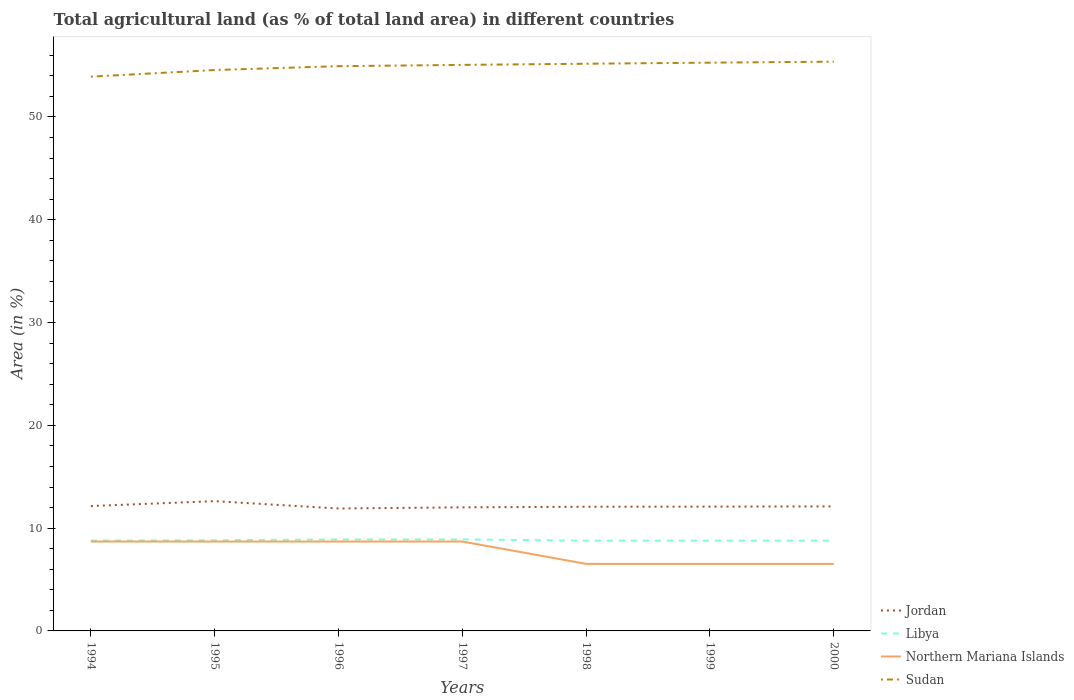Does the line corresponding to Jordan intersect with the line corresponding to Libya?
Your response must be concise. No. Is the number of lines equal to the number of legend labels?
Give a very brief answer. Yes. Across all years, what is the maximum percentage of agricultural land in Libya?
Keep it short and to the point. 8.78. What is the total percentage of agricultural land in Libya in the graph?
Provide a short and direct response. 0.12. What is the difference between the highest and the second highest percentage of agricultural land in Jordan?
Provide a succinct answer. 0.71. What is the difference between the highest and the lowest percentage of agricultural land in Northern Mariana Islands?
Offer a very short reply. 4. Is the percentage of agricultural land in Libya strictly greater than the percentage of agricultural land in Jordan over the years?
Your response must be concise. Yes. How many lines are there?
Your response must be concise. 4. How many years are there in the graph?
Your answer should be compact. 7. Does the graph contain grids?
Provide a short and direct response. No. Where does the legend appear in the graph?
Your answer should be very brief. Bottom right. How many legend labels are there?
Your response must be concise. 4. How are the legend labels stacked?
Give a very brief answer. Vertical. What is the title of the graph?
Make the answer very short. Total agricultural land (as % of total land area) in different countries. Does "Europe(developing only)" appear as one of the legend labels in the graph?
Provide a short and direct response. No. What is the label or title of the Y-axis?
Give a very brief answer. Area (in %). What is the Area (in %) of Jordan in 1994?
Provide a short and direct response. 12.15. What is the Area (in %) in Libya in 1994?
Your response must be concise. 8.79. What is the Area (in %) of Northern Mariana Islands in 1994?
Provide a short and direct response. 8.7. What is the Area (in %) in Sudan in 1994?
Your answer should be compact. 53.92. What is the Area (in %) in Jordan in 1995?
Offer a terse response. 12.62. What is the Area (in %) of Libya in 1995?
Offer a very short reply. 8.82. What is the Area (in %) of Northern Mariana Islands in 1995?
Ensure brevity in your answer.  8.7. What is the Area (in %) in Sudan in 1995?
Your answer should be compact. 54.56. What is the Area (in %) in Jordan in 1996?
Your response must be concise. 11.91. What is the Area (in %) in Libya in 1996?
Give a very brief answer. 8.9. What is the Area (in %) in Northern Mariana Islands in 1996?
Keep it short and to the point. 8.7. What is the Area (in %) of Sudan in 1996?
Keep it short and to the point. 54.94. What is the Area (in %) of Jordan in 1997?
Offer a very short reply. 12.02. What is the Area (in %) of Libya in 1997?
Your response must be concise. 8.9. What is the Area (in %) in Northern Mariana Islands in 1997?
Provide a short and direct response. 8.7. What is the Area (in %) in Sudan in 1997?
Your answer should be very brief. 55.06. What is the Area (in %) in Jordan in 1998?
Offer a very short reply. 12.08. What is the Area (in %) of Libya in 1998?
Give a very brief answer. 8.78. What is the Area (in %) of Northern Mariana Islands in 1998?
Offer a very short reply. 6.52. What is the Area (in %) in Sudan in 1998?
Ensure brevity in your answer.  55.18. What is the Area (in %) in Jordan in 1999?
Make the answer very short. 12.09. What is the Area (in %) of Libya in 1999?
Your response must be concise. 8.78. What is the Area (in %) of Northern Mariana Islands in 1999?
Keep it short and to the point. 6.52. What is the Area (in %) in Sudan in 1999?
Make the answer very short. 55.28. What is the Area (in %) of Jordan in 2000?
Your answer should be compact. 12.11. What is the Area (in %) of Libya in 2000?
Your answer should be compact. 8.78. What is the Area (in %) of Northern Mariana Islands in 2000?
Give a very brief answer. 6.52. What is the Area (in %) of Sudan in 2000?
Your response must be concise. 55.38. Across all years, what is the maximum Area (in %) in Jordan?
Offer a terse response. 12.62. Across all years, what is the maximum Area (in %) of Libya?
Ensure brevity in your answer.  8.9. Across all years, what is the maximum Area (in %) of Northern Mariana Islands?
Your answer should be compact. 8.7. Across all years, what is the maximum Area (in %) of Sudan?
Provide a succinct answer. 55.38. Across all years, what is the minimum Area (in %) of Jordan?
Provide a short and direct response. 11.91. Across all years, what is the minimum Area (in %) in Libya?
Your answer should be compact. 8.78. Across all years, what is the minimum Area (in %) in Northern Mariana Islands?
Ensure brevity in your answer.  6.52. Across all years, what is the minimum Area (in %) of Sudan?
Your response must be concise. 53.92. What is the total Area (in %) of Jordan in the graph?
Ensure brevity in your answer.  85. What is the total Area (in %) of Libya in the graph?
Your answer should be very brief. 61.76. What is the total Area (in %) of Northern Mariana Islands in the graph?
Offer a terse response. 54.35. What is the total Area (in %) of Sudan in the graph?
Ensure brevity in your answer.  384.33. What is the difference between the Area (in %) of Jordan in 1994 and that in 1995?
Ensure brevity in your answer.  -0.48. What is the difference between the Area (in %) in Libya in 1994 and that in 1995?
Your answer should be very brief. -0.02. What is the difference between the Area (in %) of Northern Mariana Islands in 1994 and that in 1995?
Your response must be concise. 0. What is the difference between the Area (in %) of Sudan in 1994 and that in 1995?
Ensure brevity in your answer.  -0.64. What is the difference between the Area (in %) in Jordan in 1994 and that in 1996?
Offer a very short reply. 0.24. What is the difference between the Area (in %) of Libya in 1994 and that in 1996?
Provide a succinct answer. -0.11. What is the difference between the Area (in %) in Sudan in 1994 and that in 1996?
Offer a terse response. -1.02. What is the difference between the Area (in %) of Jordan in 1994 and that in 1997?
Make the answer very short. 0.12. What is the difference between the Area (in %) of Libya in 1994 and that in 1997?
Keep it short and to the point. -0.11. What is the difference between the Area (in %) of Northern Mariana Islands in 1994 and that in 1997?
Ensure brevity in your answer.  0. What is the difference between the Area (in %) in Sudan in 1994 and that in 1997?
Keep it short and to the point. -1.14. What is the difference between the Area (in %) in Jordan in 1994 and that in 1998?
Keep it short and to the point. 0.07. What is the difference between the Area (in %) of Libya in 1994 and that in 1998?
Your answer should be compact. 0.01. What is the difference between the Area (in %) in Northern Mariana Islands in 1994 and that in 1998?
Make the answer very short. 2.17. What is the difference between the Area (in %) of Sudan in 1994 and that in 1998?
Ensure brevity in your answer.  -1.26. What is the difference between the Area (in %) in Jordan in 1994 and that in 1999?
Offer a very short reply. 0.06. What is the difference between the Area (in %) in Libya in 1994 and that in 1999?
Make the answer very short. 0.01. What is the difference between the Area (in %) of Northern Mariana Islands in 1994 and that in 1999?
Give a very brief answer. 2.17. What is the difference between the Area (in %) of Sudan in 1994 and that in 1999?
Your answer should be compact. -1.36. What is the difference between the Area (in %) of Jordan in 1994 and that in 2000?
Offer a terse response. 0.03. What is the difference between the Area (in %) of Libya in 1994 and that in 2000?
Keep it short and to the point. 0.01. What is the difference between the Area (in %) of Northern Mariana Islands in 1994 and that in 2000?
Provide a succinct answer. 2.17. What is the difference between the Area (in %) of Sudan in 1994 and that in 2000?
Provide a short and direct response. -1.46. What is the difference between the Area (in %) of Jordan in 1995 and that in 1996?
Provide a succinct answer. 0.71. What is the difference between the Area (in %) of Libya in 1995 and that in 1996?
Make the answer very short. -0.09. What is the difference between the Area (in %) of Northern Mariana Islands in 1995 and that in 1996?
Provide a short and direct response. 0. What is the difference between the Area (in %) in Sudan in 1995 and that in 1996?
Offer a very short reply. -0.38. What is the difference between the Area (in %) of Jordan in 1995 and that in 1997?
Provide a succinct answer. 0.6. What is the difference between the Area (in %) of Libya in 1995 and that in 1997?
Make the answer very short. -0.09. What is the difference between the Area (in %) of Northern Mariana Islands in 1995 and that in 1997?
Ensure brevity in your answer.  0. What is the difference between the Area (in %) of Sudan in 1995 and that in 1997?
Offer a terse response. -0.5. What is the difference between the Area (in %) of Jordan in 1995 and that in 1998?
Keep it short and to the point. 0.54. What is the difference between the Area (in %) of Libya in 1995 and that in 1998?
Give a very brief answer. 0.04. What is the difference between the Area (in %) in Northern Mariana Islands in 1995 and that in 1998?
Your answer should be compact. 2.17. What is the difference between the Area (in %) in Sudan in 1995 and that in 1998?
Offer a terse response. -0.61. What is the difference between the Area (in %) in Jordan in 1995 and that in 1999?
Give a very brief answer. 0.53. What is the difference between the Area (in %) of Libya in 1995 and that in 1999?
Keep it short and to the point. 0.04. What is the difference between the Area (in %) of Northern Mariana Islands in 1995 and that in 1999?
Offer a terse response. 2.17. What is the difference between the Area (in %) of Sudan in 1995 and that in 1999?
Give a very brief answer. -0.72. What is the difference between the Area (in %) of Jordan in 1995 and that in 2000?
Offer a very short reply. 0.51. What is the difference between the Area (in %) of Libya in 1995 and that in 2000?
Provide a short and direct response. 0.04. What is the difference between the Area (in %) of Northern Mariana Islands in 1995 and that in 2000?
Give a very brief answer. 2.17. What is the difference between the Area (in %) of Sudan in 1995 and that in 2000?
Offer a very short reply. -0.81. What is the difference between the Area (in %) of Jordan in 1996 and that in 1997?
Your answer should be very brief. -0.11. What is the difference between the Area (in %) in Northern Mariana Islands in 1996 and that in 1997?
Your answer should be very brief. 0. What is the difference between the Area (in %) in Sudan in 1996 and that in 1997?
Offer a terse response. -0.12. What is the difference between the Area (in %) of Jordan in 1996 and that in 1998?
Give a very brief answer. -0.17. What is the difference between the Area (in %) of Libya in 1996 and that in 1998?
Your answer should be very brief. 0.12. What is the difference between the Area (in %) of Northern Mariana Islands in 1996 and that in 1998?
Ensure brevity in your answer.  2.17. What is the difference between the Area (in %) in Sudan in 1996 and that in 1998?
Provide a succinct answer. -0.24. What is the difference between the Area (in %) in Jordan in 1996 and that in 1999?
Ensure brevity in your answer.  -0.18. What is the difference between the Area (in %) of Libya in 1996 and that in 1999?
Make the answer very short. 0.12. What is the difference between the Area (in %) in Northern Mariana Islands in 1996 and that in 1999?
Your answer should be very brief. 2.17. What is the difference between the Area (in %) of Sudan in 1996 and that in 1999?
Ensure brevity in your answer.  -0.34. What is the difference between the Area (in %) in Jordan in 1996 and that in 2000?
Offer a terse response. -0.2. What is the difference between the Area (in %) of Libya in 1996 and that in 2000?
Ensure brevity in your answer.  0.12. What is the difference between the Area (in %) in Northern Mariana Islands in 1996 and that in 2000?
Your response must be concise. 2.17. What is the difference between the Area (in %) in Sudan in 1996 and that in 2000?
Ensure brevity in your answer.  -0.44. What is the difference between the Area (in %) of Jordan in 1997 and that in 1998?
Offer a very short reply. -0.06. What is the difference between the Area (in %) in Libya in 1997 and that in 1998?
Keep it short and to the point. 0.12. What is the difference between the Area (in %) in Northern Mariana Islands in 1997 and that in 1998?
Give a very brief answer. 2.17. What is the difference between the Area (in %) in Sudan in 1997 and that in 1998?
Your answer should be very brief. -0.11. What is the difference between the Area (in %) in Jordan in 1997 and that in 1999?
Your response must be concise. -0.07. What is the difference between the Area (in %) in Libya in 1997 and that in 1999?
Offer a terse response. 0.12. What is the difference between the Area (in %) in Northern Mariana Islands in 1997 and that in 1999?
Provide a succinct answer. 2.17. What is the difference between the Area (in %) of Sudan in 1997 and that in 1999?
Your response must be concise. -0.22. What is the difference between the Area (in %) of Jordan in 1997 and that in 2000?
Offer a terse response. -0.09. What is the difference between the Area (in %) in Libya in 1997 and that in 2000?
Ensure brevity in your answer.  0.12. What is the difference between the Area (in %) in Northern Mariana Islands in 1997 and that in 2000?
Your answer should be very brief. 2.17. What is the difference between the Area (in %) in Sudan in 1997 and that in 2000?
Provide a short and direct response. -0.31. What is the difference between the Area (in %) of Jordan in 1998 and that in 1999?
Make the answer very short. -0.01. What is the difference between the Area (in %) of Libya in 1998 and that in 1999?
Your answer should be compact. 0. What is the difference between the Area (in %) in Sudan in 1998 and that in 1999?
Make the answer very short. -0.11. What is the difference between the Area (in %) of Jordan in 1998 and that in 2000?
Provide a succinct answer. -0.03. What is the difference between the Area (in %) of Northern Mariana Islands in 1998 and that in 2000?
Give a very brief answer. 0. What is the difference between the Area (in %) of Sudan in 1998 and that in 2000?
Your answer should be very brief. -0.2. What is the difference between the Area (in %) of Jordan in 1999 and that in 2000?
Offer a very short reply. -0.02. What is the difference between the Area (in %) of Libya in 1999 and that in 2000?
Your response must be concise. 0. What is the difference between the Area (in %) in Sudan in 1999 and that in 2000?
Offer a terse response. -0.09. What is the difference between the Area (in %) of Jordan in 1994 and the Area (in %) of Libya in 1995?
Your response must be concise. 3.33. What is the difference between the Area (in %) of Jordan in 1994 and the Area (in %) of Northern Mariana Islands in 1995?
Your answer should be compact. 3.45. What is the difference between the Area (in %) of Jordan in 1994 and the Area (in %) of Sudan in 1995?
Your answer should be compact. -42.42. What is the difference between the Area (in %) in Libya in 1994 and the Area (in %) in Northern Mariana Islands in 1995?
Your answer should be compact. 0.1. What is the difference between the Area (in %) in Libya in 1994 and the Area (in %) in Sudan in 1995?
Offer a very short reply. -45.77. What is the difference between the Area (in %) of Northern Mariana Islands in 1994 and the Area (in %) of Sudan in 1995?
Offer a terse response. -45.87. What is the difference between the Area (in %) of Jordan in 1994 and the Area (in %) of Libya in 1996?
Your response must be concise. 3.25. What is the difference between the Area (in %) of Jordan in 1994 and the Area (in %) of Northern Mariana Islands in 1996?
Your answer should be compact. 3.45. What is the difference between the Area (in %) in Jordan in 1994 and the Area (in %) in Sudan in 1996?
Your answer should be very brief. -42.79. What is the difference between the Area (in %) of Libya in 1994 and the Area (in %) of Northern Mariana Islands in 1996?
Offer a terse response. 0.1. What is the difference between the Area (in %) of Libya in 1994 and the Area (in %) of Sudan in 1996?
Give a very brief answer. -46.15. What is the difference between the Area (in %) of Northern Mariana Islands in 1994 and the Area (in %) of Sudan in 1996?
Your answer should be compact. -46.24. What is the difference between the Area (in %) in Jordan in 1994 and the Area (in %) in Libya in 1997?
Provide a succinct answer. 3.25. What is the difference between the Area (in %) of Jordan in 1994 and the Area (in %) of Northern Mariana Islands in 1997?
Keep it short and to the point. 3.45. What is the difference between the Area (in %) in Jordan in 1994 and the Area (in %) in Sudan in 1997?
Keep it short and to the point. -42.92. What is the difference between the Area (in %) in Libya in 1994 and the Area (in %) in Northern Mariana Islands in 1997?
Your answer should be very brief. 0.1. What is the difference between the Area (in %) in Libya in 1994 and the Area (in %) in Sudan in 1997?
Keep it short and to the point. -46.27. What is the difference between the Area (in %) of Northern Mariana Islands in 1994 and the Area (in %) of Sudan in 1997?
Provide a succinct answer. -46.37. What is the difference between the Area (in %) in Jordan in 1994 and the Area (in %) in Libya in 1998?
Your answer should be compact. 3.37. What is the difference between the Area (in %) of Jordan in 1994 and the Area (in %) of Northern Mariana Islands in 1998?
Your response must be concise. 5.63. What is the difference between the Area (in %) of Jordan in 1994 and the Area (in %) of Sudan in 1998?
Keep it short and to the point. -43.03. What is the difference between the Area (in %) of Libya in 1994 and the Area (in %) of Northern Mariana Islands in 1998?
Provide a short and direct response. 2.27. What is the difference between the Area (in %) of Libya in 1994 and the Area (in %) of Sudan in 1998?
Make the answer very short. -46.38. What is the difference between the Area (in %) of Northern Mariana Islands in 1994 and the Area (in %) of Sudan in 1998?
Ensure brevity in your answer.  -46.48. What is the difference between the Area (in %) in Jordan in 1994 and the Area (in %) in Libya in 1999?
Your response must be concise. 3.37. What is the difference between the Area (in %) in Jordan in 1994 and the Area (in %) in Northern Mariana Islands in 1999?
Offer a terse response. 5.63. What is the difference between the Area (in %) of Jordan in 1994 and the Area (in %) of Sudan in 1999?
Keep it short and to the point. -43.13. What is the difference between the Area (in %) in Libya in 1994 and the Area (in %) in Northern Mariana Islands in 1999?
Make the answer very short. 2.27. What is the difference between the Area (in %) of Libya in 1994 and the Area (in %) of Sudan in 1999?
Give a very brief answer. -46.49. What is the difference between the Area (in %) of Northern Mariana Islands in 1994 and the Area (in %) of Sudan in 1999?
Your response must be concise. -46.59. What is the difference between the Area (in %) in Jordan in 1994 and the Area (in %) in Libya in 2000?
Provide a succinct answer. 3.37. What is the difference between the Area (in %) in Jordan in 1994 and the Area (in %) in Northern Mariana Islands in 2000?
Make the answer very short. 5.63. What is the difference between the Area (in %) of Jordan in 1994 and the Area (in %) of Sudan in 2000?
Offer a terse response. -43.23. What is the difference between the Area (in %) in Libya in 1994 and the Area (in %) in Northern Mariana Islands in 2000?
Give a very brief answer. 2.27. What is the difference between the Area (in %) in Libya in 1994 and the Area (in %) in Sudan in 2000?
Your answer should be compact. -46.58. What is the difference between the Area (in %) in Northern Mariana Islands in 1994 and the Area (in %) in Sudan in 2000?
Offer a very short reply. -46.68. What is the difference between the Area (in %) of Jordan in 1995 and the Area (in %) of Libya in 1996?
Make the answer very short. 3.72. What is the difference between the Area (in %) in Jordan in 1995 and the Area (in %) in Northern Mariana Islands in 1996?
Offer a terse response. 3.93. What is the difference between the Area (in %) of Jordan in 1995 and the Area (in %) of Sudan in 1996?
Give a very brief answer. -42.32. What is the difference between the Area (in %) of Libya in 1995 and the Area (in %) of Northern Mariana Islands in 1996?
Keep it short and to the point. 0.12. What is the difference between the Area (in %) in Libya in 1995 and the Area (in %) in Sudan in 1996?
Your answer should be very brief. -46.12. What is the difference between the Area (in %) in Northern Mariana Islands in 1995 and the Area (in %) in Sudan in 1996?
Provide a short and direct response. -46.24. What is the difference between the Area (in %) of Jordan in 1995 and the Area (in %) of Libya in 1997?
Ensure brevity in your answer.  3.72. What is the difference between the Area (in %) in Jordan in 1995 and the Area (in %) in Northern Mariana Islands in 1997?
Ensure brevity in your answer.  3.93. What is the difference between the Area (in %) of Jordan in 1995 and the Area (in %) of Sudan in 1997?
Keep it short and to the point. -42.44. What is the difference between the Area (in %) of Libya in 1995 and the Area (in %) of Northern Mariana Islands in 1997?
Offer a very short reply. 0.12. What is the difference between the Area (in %) of Libya in 1995 and the Area (in %) of Sudan in 1997?
Ensure brevity in your answer.  -46.25. What is the difference between the Area (in %) of Northern Mariana Islands in 1995 and the Area (in %) of Sudan in 1997?
Offer a very short reply. -46.37. What is the difference between the Area (in %) of Jordan in 1995 and the Area (in %) of Libya in 1998?
Make the answer very short. 3.84. What is the difference between the Area (in %) in Jordan in 1995 and the Area (in %) in Northern Mariana Islands in 1998?
Ensure brevity in your answer.  6.1. What is the difference between the Area (in %) of Jordan in 1995 and the Area (in %) of Sudan in 1998?
Provide a short and direct response. -42.55. What is the difference between the Area (in %) in Libya in 1995 and the Area (in %) in Northern Mariana Islands in 1998?
Keep it short and to the point. 2.3. What is the difference between the Area (in %) of Libya in 1995 and the Area (in %) of Sudan in 1998?
Your answer should be compact. -46.36. What is the difference between the Area (in %) of Northern Mariana Islands in 1995 and the Area (in %) of Sudan in 1998?
Your answer should be very brief. -46.48. What is the difference between the Area (in %) in Jordan in 1995 and the Area (in %) in Libya in 1999?
Give a very brief answer. 3.84. What is the difference between the Area (in %) of Jordan in 1995 and the Area (in %) of Northern Mariana Islands in 1999?
Your answer should be very brief. 6.1. What is the difference between the Area (in %) in Jordan in 1995 and the Area (in %) in Sudan in 1999?
Your answer should be compact. -42.66. What is the difference between the Area (in %) of Libya in 1995 and the Area (in %) of Northern Mariana Islands in 1999?
Your answer should be compact. 2.3. What is the difference between the Area (in %) of Libya in 1995 and the Area (in %) of Sudan in 1999?
Offer a very short reply. -46.47. What is the difference between the Area (in %) in Northern Mariana Islands in 1995 and the Area (in %) in Sudan in 1999?
Offer a very short reply. -46.59. What is the difference between the Area (in %) of Jordan in 1995 and the Area (in %) of Libya in 2000?
Your answer should be very brief. 3.84. What is the difference between the Area (in %) in Jordan in 1995 and the Area (in %) in Northern Mariana Islands in 2000?
Your response must be concise. 6.1. What is the difference between the Area (in %) of Jordan in 1995 and the Area (in %) of Sudan in 2000?
Offer a terse response. -42.75. What is the difference between the Area (in %) of Libya in 1995 and the Area (in %) of Northern Mariana Islands in 2000?
Provide a short and direct response. 2.3. What is the difference between the Area (in %) in Libya in 1995 and the Area (in %) in Sudan in 2000?
Your answer should be compact. -46.56. What is the difference between the Area (in %) of Northern Mariana Islands in 1995 and the Area (in %) of Sudan in 2000?
Provide a succinct answer. -46.68. What is the difference between the Area (in %) in Jordan in 1996 and the Area (in %) in Libya in 1997?
Your answer should be compact. 3.01. What is the difference between the Area (in %) in Jordan in 1996 and the Area (in %) in Northern Mariana Islands in 1997?
Give a very brief answer. 3.21. What is the difference between the Area (in %) of Jordan in 1996 and the Area (in %) of Sudan in 1997?
Provide a succinct answer. -43.15. What is the difference between the Area (in %) of Libya in 1996 and the Area (in %) of Northern Mariana Islands in 1997?
Provide a short and direct response. 0.21. What is the difference between the Area (in %) of Libya in 1996 and the Area (in %) of Sudan in 1997?
Offer a very short reply. -46.16. What is the difference between the Area (in %) of Northern Mariana Islands in 1996 and the Area (in %) of Sudan in 1997?
Provide a short and direct response. -46.37. What is the difference between the Area (in %) in Jordan in 1996 and the Area (in %) in Libya in 1998?
Give a very brief answer. 3.13. What is the difference between the Area (in %) of Jordan in 1996 and the Area (in %) of Northern Mariana Islands in 1998?
Your response must be concise. 5.39. What is the difference between the Area (in %) in Jordan in 1996 and the Area (in %) in Sudan in 1998?
Provide a short and direct response. -43.27. What is the difference between the Area (in %) of Libya in 1996 and the Area (in %) of Northern Mariana Islands in 1998?
Give a very brief answer. 2.38. What is the difference between the Area (in %) in Libya in 1996 and the Area (in %) in Sudan in 1998?
Offer a terse response. -46.27. What is the difference between the Area (in %) of Northern Mariana Islands in 1996 and the Area (in %) of Sudan in 1998?
Keep it short and to the point. -46.48. What is the difference between the Area (in %) of Jordan in 1996 and the Area (in %) of Libya in 1999?
Ensure brevity in your answer.  3.13. What is the difference between the Area (in %) of Jordan in 1996 and the Area (in %) of Northern Mariana Islands in 1999?
Offer a very short reply. 5.39. What is the difference between the Area (in %) of Jordan in 1996 and the Area (in %) of Sudan in 1999?
Offer a very short reply. -43.37. What is the difference between the Area (in %) of Libya in 1996 and the Area (in %) of Northern Mariana Islands in 1999?
Your answer should be compact. 2.38. What is the difference between the Area (in %) in Libya in 1996 and the Area (in %) in Sudan in 1999?
Make the answer very short. -46.38. What is the difference between the Area (in %) of Northern Mariana Islands in 1996 and the Area (in %) of Sudan in 1999?
Offer a very short reply. -46.59. What is the difference between the Area (in %) in Jordan in 1996 and the Area (in %) in Libya in 2000?
Your answer should be very brief. 3.13. What is the difference between the Area (in %) in Jordan in 1996 and the Area (in %) in Northern Mariana Islands in 2000?
Provide a succinct answer. 5.39. What is the difference between the Area (in %) of Jordan in 1996 and the Area (in %) of Sudan in 2000?
Your response must be concise. -43.47. What is the difference between the Area (in %) of Libya in 1996 and the Area (in %) of Northern Mariana Islands in 2000?
Give a very brief answer. 2.38. What is the difference between the Area (in %) of Libya in 1996 and the Area (in %) of Sudan in 2000?
Provide a succinct answer. -46.47. What is the difference between the Area (in %) in Northern Mariana Islands in 1996 and the Area (in %) in Sudan in 2000?
Your answer should be compact. -46.68. What is the difference between the Area (in %) in Jordan in 1997 and the Area (in %) in Libya in 1998?
Your answer should be compact. 3.24. What is the difference between the Area (in %) of Jordan in 1997 and the Area (in %) of Northern Mariana Islands in 1998?
Your answer should be compact. 5.5. What is the difference between the Area (in %) in Jordan in 1997 and the Area (in %) in Sudan in 1998?
Keep it short and to the point. -43.15. What is the difference between the Area (in %) of Libya in 1997 and the Area (in %) of Northern Mariana Islands in 1998?
Provide a succinct answer. 2.38. What is the difference between the Area (in %) of Libya in 1997 and the Area (in %) of Sudan in 1998?
Make the answer very short. -46.27. What is the difference between the Area (in %) of Northern Mariana Islands in 1997 and the Area (in %) of Sudan in 1998?
Your response must be concise. -46.48. What is the difference between the Area (in %) of Jordan in 1997 and the Area (in %) of Libya in 1999?
Your response must be concise. 3.24. What is the difference between the Area (in %) of Jordan in 1997 and the Area (in %) of Northern Mariana Islands in 1999?
Provide a short and direct response. 5.5. What is the difference between the Area (in %) of Jordan in 1997 and the Area (in %) of Sudan in 1999?
Make the answer very short. -43.26. What is the difference between the Area (in %) in Libya in 1997 and the Area (in %) in Northern Mariana Islands in 1999?
Your answer should be very brief. 2.38. What is the difference between the Area (in %) in Libya in 1997 and the Area (in %) in Sudan in 1999?
Offer a very short reply. -46.38. What is the difference between the Area (in %) of Northern Mariana Islands in 1997 and the Area (in %) of Sudan in 1999?
Give a very brief answer. -46.59. What is the difference between the Area (in %) of Jordan in 1997 and the Area (in %) of Libya in 2000?
Provide a succinct answer. 3.24. What is the difference between the Area (in %) in Jordan in 1997 and the Area (in %) in Northern Mariana Islands in 2000?
Your answer should be compact. 5.5. What is the difference between the Area (in %) in Jordan in 1997 and the Area (in %) in Sudan in 2000?
Your answer should be very brief. -43.35. What is the difference between the Area (in %) in Libya in 1997 and the Area (in %) in Northern Mariana Islands in 2000?
Ensure brevity in your answer.  2.38. What is the difference between the Area (in %) of Libya in 1997 and the Area (in %) of Sudan in 2000?
Provide a succinct answer. -46.47. What is the difference between the Area (in %) in Northern Mariana Islands in 1997 and the Area (in %) in Sudan in 2000?
Keep it short and to the point. -46.68. What is the difference between the Area (in %) of Jordan in 1998 and the Area (in %) of Northern Mariana Islands in 1999?
Offer a terse response. 5.56. What is the difference between the Area (in %) of Jordan in 1998 and the Area (in %) of Sudan in 1999?
Give a very brief answer. -43.2. What is the difference between the Area (in %) in Libya in 1998 and the Area (in %) in Northern Mariana Islands in 1999?
Make the answer very short. 2.26. What is the difference between the Area (in %) of Libya in 1998 and the Area (in %) of Sudan in 1999?
Offer a very short reply. -46.5. What is the difference between the Area (in %) of Northern Mariana Islands in 1998 and the Area (in %) of Sudan in 1999?
Your answer should be very brief. -48.76. What is the difference between the Area (in %) of Jordan in 1998 and the Area (in %) of Northern Mariana Islands in 2000?
Offer a terse response. 5.56. What is the difference between the Area (in %) of Jordan in 1998 and the Area (in %) of Sudan in 2000?
Your answer should be very brief. -43.3. What is the difference between the Area (in %) of Libya in 1998 and the Area (in %) of Northern Mariana Islands in 2000?
Offer a terse response. 2.26. What is the difference between the Area (in %) of Libya in 1998 and the Area (in %) of Sudan in 2000?
Offer a terse response. -46.6. What is the difference between the Area (in %) in Northern Mariana Islands in 1998 and the Area (in %) in Sudan in 2000?
Provide a succinct answer. -48.85. What is the difference between the Area (in %) of Jordan in 1999 and the Area (in %) of Libya in 2000?
Provide a short and direct response. 3.31. What is the difference between the Area (in %) in Jordan in 1999 and the Area (in %) in Northern Mariana Islands in 2000?
Ensure brevity in your answer.  5.57. What is the difference between the Area (in %) of Jordan in 1999 and the Area (in %) of Sudan in 2000?
Give a very brief answer. -43.28. What is the difference between the Area (in %) of Libya in 1999 and the Area (in %) of Northern Mariana Islands in 2000?
Provide a short and direct response. 2.26. What is the difference between the Area (in %) in Libya in 1999 and the Area (in %) in Sudan in 2000?
Give a very brief answer. -46.6. What is the difference between the Area (in %) in Northern Mariana Islands in 1999 and the Area (in %) in Sudan in 2000?
Your answer should be very brief. -48.85. What is the average Area (in %) in Jordan per year?
Your response must be concise. 12.14. What is the average Area (in %) of Libya per year?
Provide a short and direct response. 8.82. What is the average Area (in %) of Northern Mariana Islands per year?
Give a very brief answer. 7.76. What is the average Area (in %) of Sudan per year?
Give a very brief answer. 54.9. In the year 1994, what is the difference between the Area (in %) of Jordan and Area (in %) of Libya?
Give a very brief answer. 3.35. In the year 1994, what is the difference between the Area (in %) in Jordan and Area (in %) in Northern Mariana Islands?
Your answer should be very brief. 3.45. In the year 1994, what is the difference between the Area (in %) in Jordan and Area (in %) in Sudan?
Ensure brevity in your answer.  -41.77. In the year 1994, what is the difference between the Area (in %) in Libya and Area (in %) in Northern Mariana Islands?
Provide a short and direct response. 0.1. In the year 1994, what is the difference between the Area (in %) of Libya and Area (in %) of Sudan?
Provide a short and direct response. -45.13. In the year 1994, what is the difference between the Area (in %) in Northern Mariana Islands and Area (in %) in Sudan?
Offer a terse response. -45.22. In the year 1995, what is the difference between the Area (in %) of Jordan and Area (in %) of Libya?
Give a very brief answer. 3.81. In the year 1995, what is the difference between the Area (in %) of Jordan and Area (in %) of Northern Mariana Islands?
Offer a very short reply. 3.93. In the year 1995, what is the difference between the Area (in %) in Jordan and Area (in %) in Sudan?
Keep it short and to the point. -41.94. In the year 1995, what is the difference between the Area (in %) in Libya and Area (in %) in Northern Mariana Islands?
Ensure brevity in your answer.  0.12. In the year 1995, what is the difference between the Area (in %) of Libya and Area (in %) of Sudan?
Your answer should be very brief. -45.75. In the year 1995, what is the difference between the Area (in %) of Northern Mariana Islands and Area (in %) of Sudan?
Make the answer very short. -45.87. In the year 1996, what is the difference between the Area (in %) of Jordan and Area (in %) of Libya?
Your answer should be compact. 3.01. In the year 1996, what is the difference between the Area (in %) of Jordan and Area (in %) of Northern Mariana Islands?
Your answer should be very brief. 3.21. In the year 1996, what is the difference between the Area (in %) of Jordan and Area (in %) of Sudan?
Provide a succinct answer. -43.03. In the year 1996, what is the difference between the Area (in %) in Libya and Area (in %) in Northern Mariana Islands?
Your answer should be very brief. 0.21. In the year 1996, what is the difference between the Area (in %) of Libya and Area (in %) of Sudan?
Keep it short and to the point. -46.04. In the year 1996, what is the difference between the Area (in %) of Northern Mariana Islands and Area (in %) of Sudan?
Your answer should be very brief. -46.24. In the year 1997, what is the difference between the Area (in %) of Jordan and Area (in %) of Libya?
Your answer should be compact. 3.12. In the year 1997, what is the difference between the Area (in %) in Jordan and Area (in %) in Northern Mariana Islands?
Give a very brief answer. 3.33. In the year 1997, what is the difference between the Area (in %) in Jordan and Area (in %) in Sudan?
Your answer should be compact. -43.04. In the year 1997, what is the difference between the Area (in %) of Libya and Area (in %) of Northern Mariana Islands?
Your answer should be very brief. 0.21. In the year 1997, what is the difference between the Area (in %) of Libya and Area (in %) of Sudan?
Ensure brevity in your answer.  -46.16. In the year 1997, what is the difference between the Area (in %) of Northern Mariana Islands and Area (in %) of Sudan?
Offer a terse response. -46.37. In the year 1998, what is the difference between the Area (in %) in Jordan and Area (in %) in Libya?
Offer a terse response. 3.3. In the year 1998, what is the difference between the Area (in %) of Jordan and Area (in %) of Northern Mariana Islands?
Offer a terse response. 5.56. In the year 1998, what is the difference between the Area (in %) in Jordan and Area (in %) in Sudan?
Your answer should be very brief. -43.1. In the year 1998, what is the difference between the Area (in %) of Libya and Area (in %) of Northern Mariana Islands?
Offer a terse response. 2.26. In the year 1998, what is the difference between the Area (in %) of Libya and Area (in %) of Sudan?
Offer a terse response. -46.4. In the year 1998, what is the difference between the Area (in %) of Northern Mariana Islands and Area (in %) of Sudan?
Your answer should be compact. -48.66. In the year 1999, what is the difference between the Area (in %) of Jordan and Area (in %) of Libya?
Your response must be concise. 3.31. In the year 1999, what is the difference between the Area (in %) in Jordan and Area (in %) in Northern Mariana Islands?
Offer a very short reply. 5.57. In the year 1999, what is the difference between the Area (in %) of Jordan and Area (in %) of Sudan?
Ensure brevity in your answer.  -43.19. In the year 1999, what is the difference between the Area (in %) in Libya and Area (in %) in Northern Mariana Islands?
Offer a very short reply. 2.26. In the year 1999, what is the difference between the Area (in %) in Libya and Area (in %) in Sudan?
Offer a very short reply. -46.5. In the year 1999, what is the difference between the Area (in %) in Northern Mariana Islands and Area (in %) in Sudan?
Ensure brevity in your answer.  -48.76. In the year 2000, what is the difference between the Area (in %) in Jordan and Area (in %) in Libya?
Provide a succinct answer. 3.33. In the year 2000, what is the difference between the Area (in %) of Jordan and Area (in %) of Northern Mariana Islands?
Your response must be concise. 5.59. In the year 2000, what is the difference between the Area (in %) of Jordan and Area (in %) of Sudan?
Provide a succinct answer. -43.26. In the year 2000, what is the difference between the Area (in %) of Libya and Area (in %) of Northern Mariana Islands?
Your answer should be very brief. 2.26. In the year 2000, what is the difference between the Area (in %) of Libya and Area (in %) of Sudan?
Offer a terse response. -46.6. In the year 2000, what is the difference between the Area (in %) of Northern Mariana Islands and Area (in %) of Sudan?
Provide a succinct answer. -48.85. What is the ratio of the Area (in %) of Jordan in 1994 to that in 1995?
Your response must be concise. 0.96. What is the ratio of the Area (in %) of Sudan in 1994 to that in 1995?
Your answer should be compact. 0.99. What is the ratio of the Area (in %) in Jordan in 1994 to that in 1996?
Ensure brevity in your answer.  1.02. What is the ratio of the Area (in %) of Sudan in 1994 to that in 1996?
Your response must be concise. 0.98. What is the ratio of the Area (in %) in Jordan in 1994 to that in 1997?
Make the answer very short. 1.01. What is the ratio of the Area (in %) of Sudan in 1994 to that in 1997?
Your response must be concise. 0.98. What is the ratio of the Area (in %) in Jordan in 1994 to that in 1998?
Ensure brevity in your answer.  1.01. What is the ratio of the Area (in %) in Sudan in 1994 to that in 1998?
Ensure brevity in your answer.  0.98. What is the ratio of the Area (in %) in Libya in 1994 to that in 1999?
Provide a succinct answer. 1. What is the ratio of the Area (in %) in Northern Mariana Islands in 1994 to that in 1999?
Your answer should be very brief. 1.33. What is the ratio of the Area (in %) of Sudan in 1994 to that in 1999?
Provide a succinct answer. 0.98. What is the ratio of the Area (in %) in Northern Mariana Islands in 1994 to that in 2000?
Offer a terse response. 1.33. What is the ratio of the Area (in %) of Sudan in 1994 to that in 2000?
Ensure brevity in your answer.  0.97. What is the ratio of the Area (in %) of Jordan in 1995 to that in 1996?
Your answer should be compact. 1.06. What is the ratio of the Area (in %) in Northern Mariana Islands in 1995 to that in 1996?
Provide a succinct answer. 1. What is the ratio of the Area (in %) of Sudan in 1995 to that in 1996?
Ensure brevity in your answer.  0.99. What is the ratio of the Area (in %) of Northern Mariana Islands in 1995 to that in 1997?
Your answer should be compact. 1. What is the ratio of the Area (in %) in Sudan in 1995 to that in 1997?
Your answer should be very brief. 0.99. What is the ratio of the Area (in %) of Jordan in 1995 to that in 1998?
Offer a very short reply. 1.04. What is the ratio of the Area (in %) of Northern Mariana Islands in 1995 to that in 1998?
Provide a short and direct response. 1.33. What is the ratio of the Area (in %) in Sudan in 1995 to that in 1998?
Your response must be concise. 0.99. What is the ratio of the Area (in %) of Jordan in 1995 to that in 1999?
Your answer should be compact. 1.04. What is the ratio of the Area (in %) of Jordan in 1995 to that in 2000?
Your answer should be compact. 1.04. What is the ratio of the Area (in %) of Northern Mariana Islands in 1995 to that in 2000?
Your answer should be compact. 1.33. What is the ratio of the Area (in %) of Jordan in 1996 to that in 1997?
Your response must be concise. 0.99. What is the ratio of the Area (in %) of Northern Mariana Islands in 1996 to that in 1997?
Provide a short and direct response. 1. What is the ratio of the Area (in %) of Jordan in 1996 to that in 1998?
Ensure brevity in your answer.  0.99. What is the ratio of the Area (in %) of Northern Mariana Islands in 1996 to that in 1998?
Offer a very short reply. 1.33. What is the ratio of the Area (in %) in Sudan in 1996 to that in 1998?
Your answer should be very brief. 1. What is the ratio of the Area (in %) of Jordan in 1996 to that in 1999?
Offer a very short reply. 0.98. What is the ratio of the Area (in %) in Libya in 1996 to that in 1999?
Provide a succinct answer. 1.01. What is the ratio of the Area (in %) of Jordan in 1996 to that in 2000?
Your answer should be compact. 0.98. What is the ratio of the Area (in %) in Jordan in 1997 to that in 1998?
Your response must be concise. 1. What is the ratio of the Area (in %) of Sudan in 1997 to that in 1998?
Make the answer very short. 1. What is the ratio of the Area (in %) in Jordan in 1997 to that in 1999?
Keep it short and to the point. 0.99. What is the ratio of the Area (in %) of Libya in 1997 to that in 1999?
Make the answer very short. 1.01. What is the ratio of the Area (in %) of Northern Mariana Islands in 1997 to that in 1999?
Ensure brevity in your answer.  1.33. What is the ratio of the Area (in %) of Sudan in 1997 to that in 1999?
Your response must be concise. 1. What is the ratio of the Area (in %) of Libya in 1997 to that in 2000?
Your answer should be very brief. 1.01. What is the ratio of the Area (in %) in Jordan in 1998 to that in 1999?
Your answer should be compact. 1. What is the ratio of the Area (in %) of Libya in 1998 to that in 1999?
Offer a terse response. 1. What is the ratio of the Area (in %) in Sudan in 1998 to that in 1999?
Your response must be concise. 1. What is the ratio of the Area (in %) in Jordan in 1998 to that in 2000?
Give a very brief answer. 1. What is the ratio of the Area (in %) of Northern Mariana Islands in 1998 to that in 2000?
Ensure brevity in your answer.  1. What is the ratio of the Area (in %) in Sudan in 1999 to that in 2000?
Your answer should be compact. 1. What is the difference between the highest and the second highest Area (in %) of Jordan?
Your answer should be very brief. 0.48. What is the difference between the highest and the second highest Area (in %) of Libya?
Offer a terse response. 0. What is the difference between the highest and the second highest Area (in %) of Sudan?
Your response must be concise. 0.09. What is the difference between the highest and the lowest Area (in %) of Jordan?
Make the answer very short. 0.71. What is the difference between the highest and the lowest Area (in %) in Libya?
Your response must be concise. 0.12. What is the difference between the highest and the lowest Area (in %) of Northern Mariana Islands?
Make the answer very short. 2.17. What is the difference between the highest and the lowest Area (in %) in Sudan?
Your response must be concise. 1.46. 